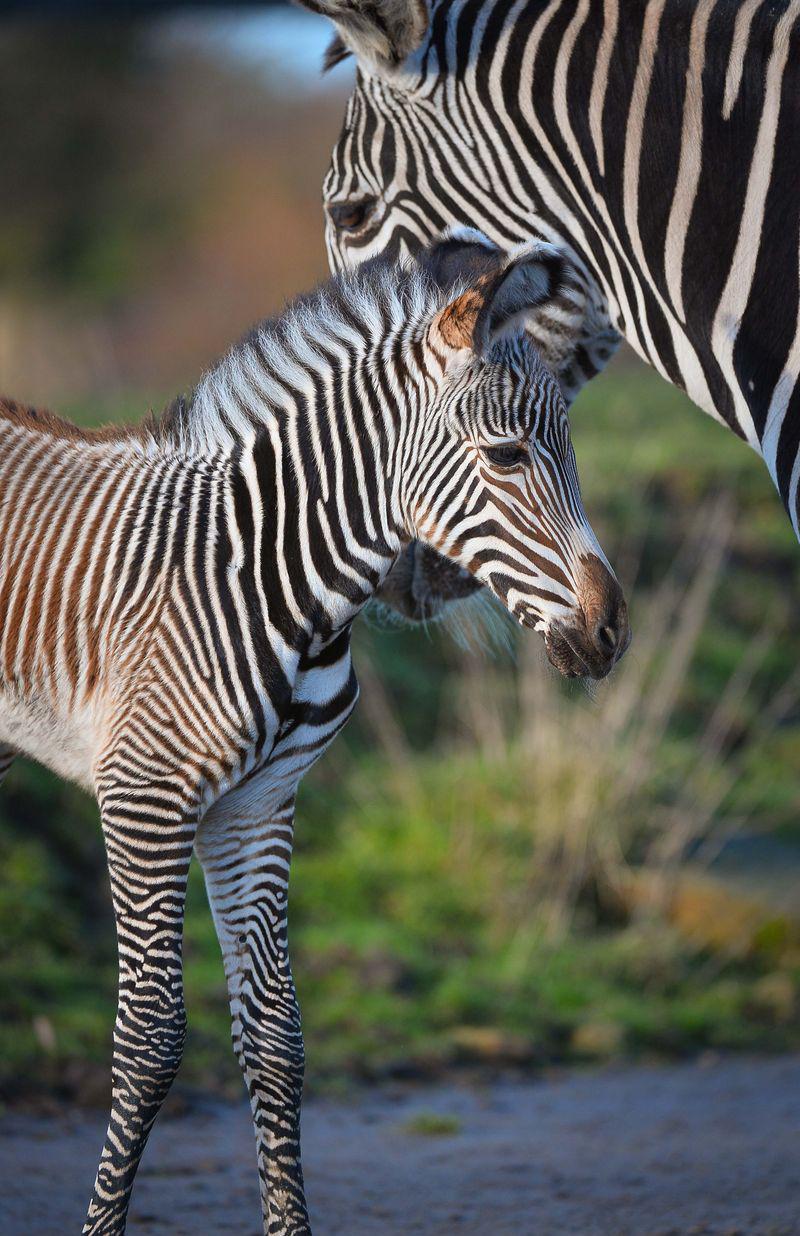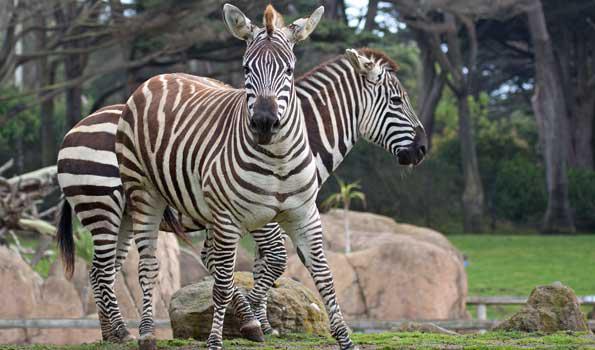The first image is the image on the left, the second image is the image on the right. Evaluate the accuracy of this statement regarding the images: "There is a baby zebra standing next to an adult zebra.". Is it true? Answer yes or no. Yes. 